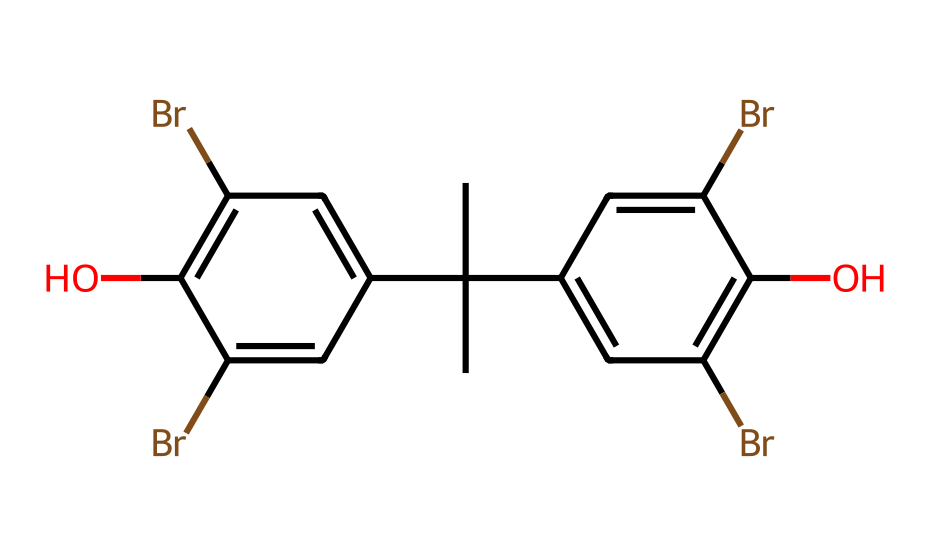How many carbon atoms are in the structure? Analyzing the SMILES representation, we identify the carbon atoms represented by 'C'. By counting, we note there are 15 carbon atoms in total.
Answer: 15 What functional groups are present in this chemical? Looking at the SMILES, we see 'Br' for bromine and 'O' for oxygen. 'Br' indicates bromine atoms, while 'O' represents hydroxyl (-OH) functional groups. Thus, there are bromine and hydroxyl groups.
Answer: bromine and hydroxyl Which type of geometric isomers might exist for this chemical? The presence of double bonds and restricted bond rotation allows for geometric isomerism. Here, the "cis" configuration refers to both substituents being on the same side, while "trans" would have them on opposite sides, suggesting both types may be possible due to various substituents' positioning.
Answer: cis and trans What is the main characteristic that defines this chemical as having geometric isomers? The presence of double bonds or a configuration that restricts rotation allows for distinct spatial arrangements of substituents, crucial for the existence of geometric isomers. The structure contains multiple aromatic rings, creating potential for such isomers.
Answer: restricted rotation How many bromine substituents are attached to the aromatic rings? By observing the structure through the SMILES, we find there are four 'Br' elements indicated, which represent bromine substituents on the aromatic rings.
Answer: four What does the presence of multiple substituents on the aromatic rings imply for the chemical's properties? Multiple substituents can affect the chemical's reactivity, polarity, and overall stability. In particular, with the added bromine atoms, this can increase flame-retardant properties and alter solubility as well as potential toxicity in older electronics.
Answer: modified properties 